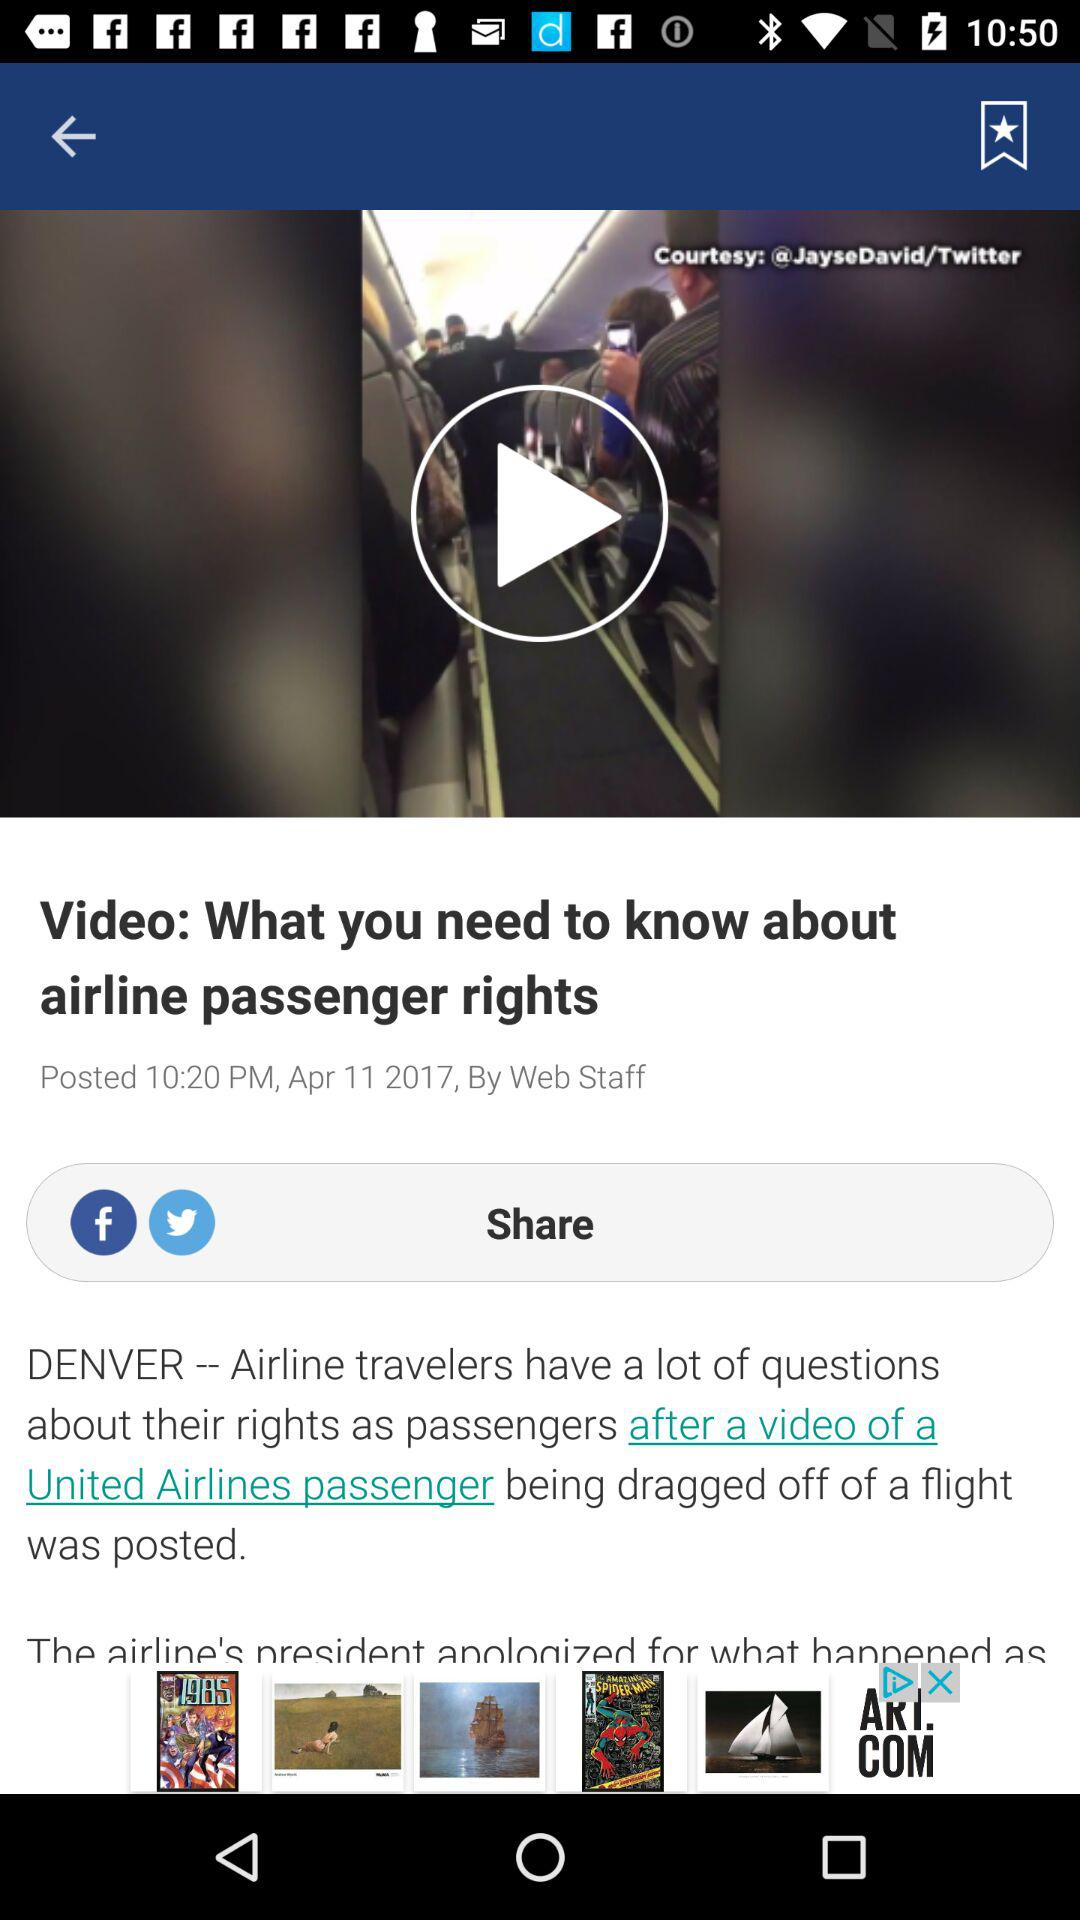Who is the author of the article? The author of the article is "Web Staff". 